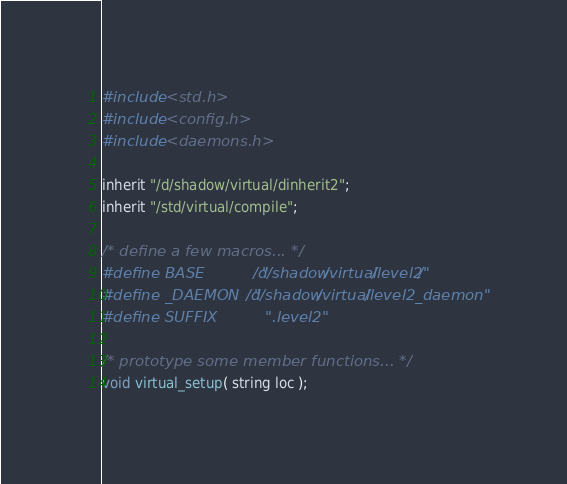<code> <loc_0><loc_0><loc_500><loc_500><_C_>#include <std.h>
#include <config.h>
#include <daemons.h>

inherit "/d/shadow/virtual/dinherit2";
inherit "/std/virtual/compile";

/* define a few macros... */
#define BASE            "/d/shadow/virtual/level2/"
#define _DAEMON   "/d/shadow/virtual/level2_daemon"
#define SUFFIX          ".level2"

/* prototype some member functions... */
void virtual_setup( string loc );</code> 